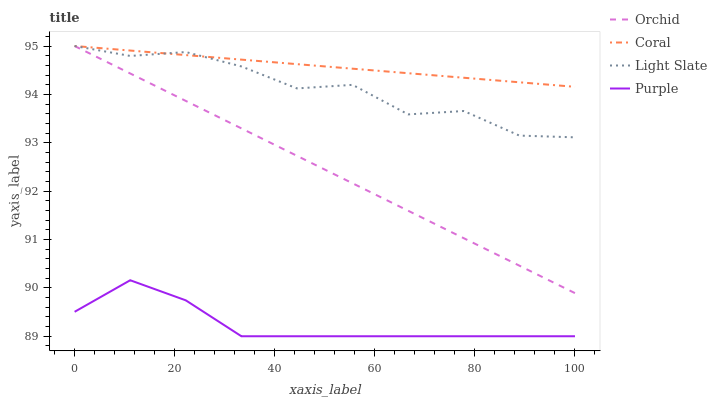Does Purple have the minimum area under the curve?
Answer yes or no. Yes. Does Coral have the maximum area under the curve?
Answer yes or no. Yes. Does Coral have the minimum area under the curve?
Answer yes or no. No. Does Purple have the maximum area under the curve?
Answer yes or no. No. Is Coral the smoothest?
Answer yes or no. Yes. Is Light Slate the roughest?
Answer yes or no. Yes. Is Purple the smoothest?
Answer yes or no. No. Is Purple the roughest?
Answer yes or no. No. Does Purple have the lowest value?
Answer yes or no. Yes. Does Coral have the lowest value?
Answer yes or no. No. Does Orchid have the highest value?
Answer yes or no. Yes. Does Purple have the highest value?
Answer yes or no. No. Is Purple less than Orchid?
Answer yes or no. Yes. Is Coral greater than Purple?
Answer yes or no. Yes. Does Orchid intersect Light Slate?
Answer yes or no. Yes. Is Orchid less than Light Slate?
Answer yes or no. No. Is Orchid greater than Light Slate?
Answer yes or no. No. Does Purple intersect Orchid?
Answer yes or no. No. 